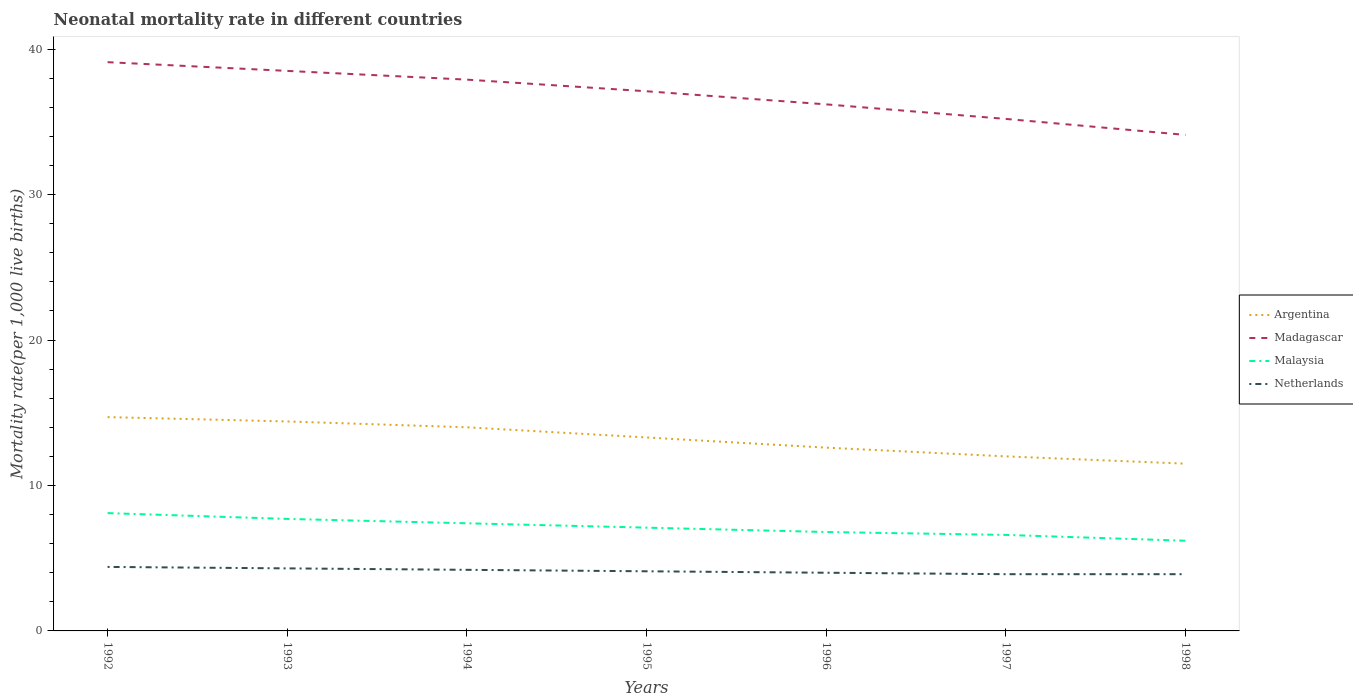How many different coloured lines are there?
Offer a terse response. 4. Does the line corresponding to Malaysia intersect with the line corresponding to Madagascar?
Offer a terse response. No. Is the number of lines equal to the number of legend labels?
Offer a very short reply. Yes. In which year was the neonatal mortality rate in Madagascar maximum?
Offer a very short reply. 1998. What is the difference between the highest and the second highest neonatal mortality rate in Madagascar?
Offer a terse response. 5. What is the difference between the highest and the lowest neonatal mortality rate in Madagascar?
Keep it short and to the point. 4. What is the difference between two consecutive major ticks on the Y-axis?
Give a very brief answer. 10. Does the graph contain any zero values?
Your response must be concise. No. How many legend labels are there?
Keep it short and to the point. 4. How are the legend labels stacked?
Provide a short and direct response. Vertical. What is the title of the graph?
Keep it short and to the point. Neonatal mortality rate in different countries. What is the label or title of the Y-axis?
Your answer should be very brief. Mortality rate(per 1,0 live births). What is the Mortality rate(per 1,000 live births) in Madagascar in 1992?
Offer a very short reply. 39.1. What is the Mortality rate(per 1,000 live births) in Malaysia in 1992?
Provide a succinct answer. 8.1. What is the Mortality rate(per 1,000 live births) in Madagascar in 1993?
Give a very brief answer. 38.5. What is the Mortality rate(per 1,000 live births) in Netherlands in 1993?
Ensure brevity in your answer.  4.3. What is the Mortality rate(per 1,000 live births) of Argentina in 1994?
Your answer should be compact. 14. What is the Mortality rate(per 1,000 live births) in Madagascar in 1994?
Give a very brief answer. 37.9. What is the Mortality rate(per 1,000 live births) of Madagascar in 1995?
Give a very brief answer. 37.1. What is the Mortality rate(per 1,000 live births) in Madagascar in 1996?
Provide a succinct answer. 36.2. What is the Mortality rate(per 1,000 live births) of Madagascar in 1997?
Offer a terse response. 35.2. What is the Mortality rate(per 1,000 live births) in Netherlands in 1997?
Your response must be concise. 3.9. What is the Mortality rate(per 1,000 live births) in Argentina in 1998?
Your answer should be compact. 11.5. What is the Mortality rate(per 1,000 live births) in Madagascar in 1998?
Offer a very short reply. 34.1. What is the Mortality rate(per 1,000 live births) of Malaysia in 1998?
Provide a succinct answer. 6.2. What is the Mortality rate(per 1,000 live births) in Netherlands in 1998?
Make the answer very short. 3.9. Across all years, what is the maximum Mortality rate(per 1,000 live births) of Argentina?
Your answer should be compact. 14.7. Across all years, what is the maximum Mortality rate(per 1,000 live births) in Madagascar?
Your answer should be compact. 39.1. Across all years, what is the minimum Mortality rate(per 1,000 live births) of Madagascar?
Keep it short and to the point. 34.1. Across all years, what is the minimum Mortality rate(per 1,000 live births) of Malaysia?
Offer a very short reply. 6.2. What is the total Mortality rate(per 1,000 live births) in Argentina in the graph?
Offer a very short reply. 92.5. What is the total Mortality rate(per 1,000 live births) in Madagascar in the graph?
Make the answer very short. 258.1. What is the total Mortality rate(per 1,000 live births) in Malaysia in the graph?
Ensure brevity in your answer.  49.9. What is the total Mortality rate(per 1,000 live births) of Netherlands in the graph?
Keep it short and to the point. 28.8. What is the difference between the Mortality rate(per 1,000 live births) in Argentina in 1992 and that in 1994?
Offer a very short reply. 0.7. What is the difference between the Mortality rate(per 1,000 live births) of Netherlands in 1992 and that in 1994?
Provide a short and direct response. 0.2. What is the difference between the Mortality rate(per 1,000 live births) of Malaysia in 1992 and that in 1995?
Ensure brevity in your answer.  1. What is the difference between the Mortality rate(per 1,000 live births) in Netherlands in 1992 and that in 1995?
Keep it short and to the point. 0.3. What is the difference between the Mortality rate(per 1,000 live births) of Argentina in 1992 and that in 1997?
Offer a very short reply. 2.7. What is the difference between the Mortality rate(per 1,000 live births) in Malaysia in 1992 and that in 1997?
Your response must be concise. 1.5. What is the difference between the Mortality rate(per 1,000 live births) in Netherlands in 1992 and that in 1997?
Ensure brevity in your answer.  0.5. What is the difference between the Mortality rate(per 1,000 live births) of Argentina in 1992 and that in 1998?
Ensure brevity in your answer.  3.2. What is the difference between the Mortality rate(per 1,000 live births) in Madagascar in 1992 and that in 1998?
Provide a succinct answer. 5. What is the difference between the Mortality rate(per 1,000 live births) in Madagascar in 1993 and that in 1994?
Give a very brief answer. 0.6. What is the difference between the Mortality rate(per 1,000 live births) in Malaysia in 1993 and that in 1994?
Your answer should be compact. 0.3. What is the difference between the Mortality rate(per 1,000 live births) in Netherlands in 1993 and that in 1994?
Ensure brevity in your answer.  0.1. What is the difference between the Mortality rate(per 1,000 live births) in Argentina in 1993 and that in 1995?
Your answer should be compact. 1.1. What is the difference between the Mortality rate(per 1,000 live births) in Madagascar in 1993 and that in 1995?
Keep it short and to the point. 1.4. What is the difference between the Mortality rate(per 1,000 live births) of Netherlands in 1993 and that in 1995?
Provide a short and direct response. 0.2. What is the difference between the Mortality rate(per 1,000 live births) in Madagascar in 1993 and that in 1996?
Your answer should be compact. 2.3. What is the difference between the Mortality rate(per 1,000 live births) in Malaysia in 1993 and that in 1996?
Your answer should be compact. 0.9. What is the difference between the Mortality rate(per 1,000 live births) of Netherlands in 1993 and that in 1996?
Provide a short and direct response. 0.3. What is the difference between the Mortality rate(per 1,000 live births) in Argentina in 1993 and that in 1997?
Offer a terse response. 2.4. What is the difference between the Mortality rate(per 1,000 live births) in Madagascar in 1993 and that in 1997?
Offer a very short reply. 3.3. What is the difference between the Mortality rate(per 1,000 live births) of Argentina in 1993 and that in 1998?
Make the answer very short. 2.9. What is the difference between the Mortality rate(per 1,000 live births) in Madagascar in 1993 and that in 1998?
Offer a very short reply. 4.4. What is the difference between the Mortality rate(per 1,000 live births) in Argentina in 1994 and that in 1995?
Make the answer very short. 0.7. What is the difference between the Mortality rate(per 1,000 live births) in Madagascar in 1994 and that in 1995?
Ensure brevity in your answer.  0.8. What is the difference between the Mortality rate(per 1,000 live births) of Malaysia in 1994 and that in 1995?
Your answer should be compact. 0.3. What is the difference between the Mortality rate(per 1,000 live births) of Argentina in 1994 and that in 1996?
Your response must be concise. 1.4. What is the difference between the Mortality rate(per 1,000 live births) of Malaysia in 1994 and that in 1996?
Offer a very short reply. 0.6. What is the difference between the Mortality rate(per 1,000 live births) in Madagascar in 1994 and that in 1997?
Make the answer very short. 2.7. What is the difference between the Mortality rate(per 1,000 live births) of Malaysia in 1994 and that in 1997?
Your answer should be very brief. 0.8. What is the difference between the Mortality rate(per 1,000 live births) of Malaysia in 1994 and that in 1998?
Keep it short and to the point. 1.2. What is the difference between the Mortality rate(per 1,000 live births) in Netherlands in 1994 and that in 1998?
Provide a succinct answer. 0.3. What is the difference between the Mortality rate(per 1,000 live births) in Argentina in 1995 and that in 1996?
Provide a succinct answer. 0.7. What is the difference between the Mortality rate(per 1,000 live births) in Madagascar in 1995 and that in 1996?
Offer a terse response. 0.9. What is the difference between the Mortality rate(per 1,000 live births) of Malaysia in 1995 and that in 1996?
Offer a very short reply. 0.3. What is the difference between the Mortality rate(per 1,000 live births) in Netherlands in 1995 and that in 1996?
Your response must be concise. 0.1. What is the difference between the Mortality rate(per 1,000 live births) in Argentina in 1995 and that in 1997?
Your answer should be very brief. 1.3. What is the difference between the Mortality rate(per 1,000 live births) of Madagascar in 1995 and that in 1997?
Your answer should be very brief. 1.9. What is the difference between the Mortality rate(per 1,000 live births) of Argentina in 1996 and that in 1997?
Keep it short and to the point. 0.6. What is the difference between the Mortality rate(per 1,000 live births) in Madagascar in 1996 and that in 1998?
Ensure brevity in your answer.  2.1. What is the difference between the Mortality rate(per 1,000 live births) of Argentina in 1997 and that in 1998?
Your answer should be compact. 0.5. What is the difference between the Mortality rate(per 1,000 live births) in Malaysia in 1997 and that in 1998?
Your answer should be very brief. 0.4. What is the difference between the Mortality rate(per 1,000 live births) in Netherlands in 1997 and that in 1998?
Your answer should be compact. 0. What is the difference between the Mortality rate(per 1,000 live births) of Argentina in 1992 and the Mortality rate(per 1,000 live births) of Madagascar in 1993?
Your response must be concise. -23.8. What is the difference between the Mortality rate(per 1,000 live births) in Argentina in 1992 and the Mortality rate(per 1,000 live births) in Netherlands in 1993?
Offer a terse response. 10.4. What is the difference between the Mortality rate(per 1,000 live births) in Madagascar in 1992 and the Mortality rate(per 1,000 live births) in Malaysia in 1993?
Offer a very short reply. 31.4. What is the difference between the Mortality rate(per 1,000 live births) of Madagascar in 1992 and the Mortality rate(per 1,000 live births) of Netherlands in 1993?
Offer a terse response. 34.8. What is the difference between the Mortality rate(per 1,000 live births) in Malaysia in 1992 and the Mortality rate(per 1,000 live births) in Netherlands in 1993?
Provide a succinct answer. 3.8. What is the difference between the Mortality rate(per 1,000 live births) of Argentina in 1992 and the Mortality rate(per 1,000 live births) of Madagascar in 1994?
Make the answer very short. -23.2. What is the difference between the Mortality rate(per 1,000 live births) of Argentina in 1992 and the Mortality rate(per 1,000 live births) of Netherlands in 1994?
Make the answer very short. 10.5. What is the difference between the Mortality rate(per 1,000 live births) of Madagascar in 1992 and the Mortality rate(per 1,000 live births) of Malaysia in 1994?
Provide a succinct answer. 31.7. What is the difference between the Mortality rate(per 1,000 live births) of Madagascar in 1992 and the Mortality rate(per 1,000 live births) of Netherlands in 1994?
Keep it short and to the point. 34.9. What is the difference between the Mortality rate(per 1,000 live births) in Malaysia in 1992 and the Mortality rate(per 1,000 live births) in Netherlands in 1994?
Provide a short and direct response. 3.9. What is the difference between the Mortality rate(per 1,000 live births) in Argentina in 1992 and the Mortality rate(per 1,000 live births) in Madagascar in 1995?
Keep it short and to the point. -22.4. What is the difference between the Mortality rate(per 1,000 live births) in Argentina in 1992 and the Mortality rate(per 1,000 live births) in Netherlands in 1995?
Make the answer very short. 10.6. What is the difference between the Mortality rate(per 1,000 live births) of Madagascar in 1992 and the Mortality rate(per 1,000 live births) of Netherlands in 1995?
Provide a succinct answer. 35. What is the difference between the Mortality rate(per 1,000 live births) of Malaysia in 1992 and the Mortality rate(per 1,000 live births) of Netherlands in 1995?
Offer a very short reply. 4. What is the difference between the Mortality rate(per 1,000 live births) of Argentina in 1992 and the Mortality rate(per 1,000 live births) of Madagascar in 1996?
Your response must be concise. -21.5. What is the difference between the Mortality rate(per 1,000 live births) of Madagascar in 1992 and the Mortality rate(per 1,000 live births) of Malaysia in 1996?
Your answer should be very brief. 32.3. What is the difference between the Mortality rate(per 1,000 live births) of Madagascar in 1992 and the Mortality rate(per 1,000 live births) of Netherlands in 1996?
Your response must be concise. 35.1. What is the difference between the Mortality rate(per 1,000 live births) of Malaysia in 1992 and the Mortality rate(per 1,000 live births) of Netherlands in 1996?
Offer a terse response. 4.1. What is the difference between the Mortality rate(per 1,000 live births) in Argentina in 1992 and the Mortality rate(per 1,000 live births) in Madagascar in 1997?
Your answer should be compact. -20.5. What is the difference between the Mortality rate(per 1,000 live births) of Argentina in 1992 and the Mortality rate(per 1,000 live births) of Netherlands in 1997?
Your answer should be very brief. 10.8. What is the difference between the Mortality rate(per 1,000 live births) of Madagascar in 1992 and the Mortality rate(per 1,000 live births) of Malaysia in 1997?
Give a very brief answer. 32.5. What is the difference between the Mortality rate(per 1,000 live births) of Madagascar in 1992 and the Mortality rate(per 1,000 live births) of Netherlands in 1997?
Keep it short and to the point. 35.2. What is the difference between the Mortality rate(per 1,000 live births) in Malaysia in 1992 and the Mortality rate(per 1,000 live births) in Netherlands in 1997?
Provide a short and direct response. 4.2. What is the difference between the Mortality rate(per 1,000 live births) in Argentina in 1992 and the Mortality rate(per 1,000 live births) in Madagascar in 1998?
Offer a very short reply. -19.4. What is the difference between the Mortality rate(per 1,000 live births) in Argentina in 1992 and the Mortality rate(per 1,000 live births) in Netherlands in 1998?
Ensure brevity in your answer.  10.8. What is the difference between the Mortality rate(per 1,000 live births) of Madagascar in 1992 and the Mortality rate(per 1,000 live births) of Malaysia in 1998?
Offer a terse response. 32.9. What is the difference between the Mortality rate(per 1,000 live births) of Madagascar in 1992 and the Mortality rate(per 1,000 live births) of Netherlands in 1998?
Offer a terse response. 35.2. What is the difference between the Mortality rate(per 1,000 live births) of Malaysia in 1992 and the Mortality rate(per 1,000 live births) of Netherlands in 1998?
Offer a terse response. 4.2. What is the difference between the Mortality rate(per 1,000 live births) in Argentina in 1993 and the Mortality rate(per 1,000 live births) in Madagascar in 1994?
Your answer should be compact. -23.5. What is the difference between the Mortality rate(per 1,000 live births) in Argentina in 1993 and the Mortality rate(per 1,000 live births) in Netherlands in 1994?
Offer a terse response. 10.2. What is the difference between the Mortality rate(per 1,000 live births) in Madagascar in 1993 and the Mortality rate(per 1,000 live births) in Malaysia in 1994?
Ensure brevity in your answer.  31.1. What is the difference between the Mortality rate(per 1,000 live births) of Madagascar in 1993 and the Mortality rate(per 1,000 live births) of Netherlands in 1994?
Make the answer very short. 34.3. What is the difference between the Mortality rate(per 1,000 live births) of Argentina in 1993 and the Mortality rate(per 1,000 live births) of Madagascar in 1995?
Give a very brief answer. -22.7. What is the difference between the Mortality rate(per 1,000 live births) in Argentina in 1993 and the Mortality rate(per 1,000 live births) in Malaysia in 1995?
Keep it short and to the point. 7.3. What is the difference between the Mortality rate(per 1,000 live births) in Argentina in 1993 and the Mortality rate(per 1,000 live births) in Netherlands in 1995?
Offer a terse response. 10.3. What is the difference between the Mortality rate(per 1,000 live births) in Madagascar in 1993 and the Mortality rate(per 1,000 live births) in Malaysia in 1995?
Provide a short and direct response. 31.4. What is the difference between the Mortality rate(per 1,000 live births) in Madagascar in 1993 and the Mortality rate(per 1,000 live births) in Netherlands in 1995?
Ensure brevity in your answer.  34.4. What is the difference between the Mortality rate(per 1,000 live births) of Malaysia in 1993 and the Mortality rate(per 1,000 live births) of Netherlands in 1995?
Your response must be concise. 3.6. What is the difference between the Mortality rate(per 1,000 live births) in Argentina in 1993 and the Mortality rate(per 1,000 live births) in Madagascar in 1996?
Keep it short and to the point. -21.8. What is the difference between the Mortality rate(per 1,000 live births) of Argentina in 1993 and the Mortality rate(per 1,000 live births) of Malaysia in 1996?
Offer a terse response. 7.6. What is the difference between the Mortality rate(per 1,000 live births) of Madagascar in 1993 and the Mortality rate(per 1,000 live births) of Malaysia in 1996?
Provide a short and direct response. 31.7. What is the difference between the Mortality rate(per 1,000 live births) of Madagascar in 1993 and the Mortality rate(per 1,000 live births) of Netherlands in 1996?
Make the answer very short. 34.5. What is the difference between the Mortality rate(per 1,000 live births) in Argentina in 1993 and the Mortality rate(per 1,000 live births) in Madagascar in 1997?
Your answer should be compact. -20.8. What is the difference between the Mortality rate(per 1,000 live births) of Madagascar in 1993 and the Mortality rate(per 1,000 live births) of Malaysia in 1997?
Your response must be concise. 31.9. What is the difference between the Mortality rate(per 1,000 live births) in Madagascar in 1993 and the Mortality rate(per 1,000 live births) in Netherlands in 1997?
Your answer should be compact. 34.6. What is the difference between the Mortality rate(per 1,000 live births) in Malaysia in 1993 and the Mortality rate(per 1,000 live births) in Netherlands in 1997?
Provide a short and direct response. 3.8. What is the difference between the Mortality rate(per 1,000 live births) of Argentina in 1993 and the Mortality rate(per 1,000 live births) of Madagascar in 1998?
Ensure brevity in your answer.  -19.7. What is the difference between the Mortality rate(per 1,000 live births) of Argentina in 1993 and the Mortality rate(per 1,000 live births) of Netherlands in 1998?
Provide a succinct answer. 10.5. What is the difference between the Mortality rate(per 1,000 live births) in Madagascar in 1993 and the Mortality rate(per 1,000 live births) in Malaysia in 1998?
Your response must be concise. 32.3. What is the difference between the Mortality rate(per 1,000 live births) in Madagascar in 1993 and the Mortality rate(per 1,000 live births) in Netherlands in 1998?
Provide a succinct answer. 34.6. What is the difference between the Mortality rate(per 1,000 live births) of Malaysia in 1993 and the Mortality rate(per 1,000 live births) of Netherlands in 1998?
Your response must be concise. 3.8. What is the difference between the Mortality rate(per 1,000 live births) in Argentina in 1994 and the Mortality rate(per 1,000 live births) in Madagascar in 1995?
Keep it short and to the point. -23.1. What is the difference between the Mortality rate(per 1,000 live births) of Argentina in 1994 and the Mortality rate(per 1,000 live births) of Malaysia in 1995?
Keep it short and to the point. 6.9. What is the difference between the Mortality rate(per 1,000 live births) of Argentina in 1994 and the Mortality rate(per 1,000 live births) of Netherlands in 1995?
Your response must be concise. 9.9. What is the difference between the Mortality rate(per 1,000 live births) of Madagascar in 1994 and the Mortality rate(per 1,000 live births) of Malaysia in 1995?
Offer a very short reply. 30.8. What is the difference between the Mortality rate(per 1,000 live births) of Madagascar in 1994 and the Mortality rate(per 1,000 live births) of Netherlands in 1995?
Keep it short and to the point. 33.8. What is the difference between the Mortality rate(per 1,000 live births) of Malaysia in 1994 and the Mortality rate(per 1,000 live births) of Netherlands in 1995?
Offer a terse response. 3.3. What is the difference between the Mortality rate(per 1,000 live births) in Argentina in 1994 and the Mortality rate(per 1,000 live births) in Madagascar in 1996?
Provide a succinct answer. -22.2. What is the difference between the Mortality rate(per 1,000 live births) in Argentina in 1994 and the Mortality rate(per 1,000 live births) in Netherlands in 1996?
Offer a very short reply. 10. What is the difference between the Mortality rate(per 1,000 live births) of Madagascar in 1994 and the Mortality rate(per 1,000 live births) of Malaysia in 1996?
Your answer should be very brief. 31.1. What is the difference between the Mortality rate(per 1,000 live births) in Madagascar in 1994 and the Mortality rate(per 1,000 live births) in Netherlands in 1996?
Ensure brevity in your answer.  33.9. What is the difference between the Mortality rate(per 1,000 live births) in Argentina in 1994 and the Mortality rate(per 1,000 live births) in Madagascar in 1997?
Your response must be concise. -21.2. What is the difference between the Mortality rate(per 1,000 live births) of Argentina in 1994 and the Mortality rate(per 1,000 live births) of Malaysia in 1997?
Your answer should be very brief. 7.4. What is the difference between the Mortality rate(per 1,000 live births) of Madagascar in 1994 and the Mortality rate(per 1,000 live births) of Malaysia in 1997?
Provide a succinct answer. 31.3. What is the difference between the Mortality rate(per 1,000 live births) of Madagascar in 1994 and the Mortality rate(per 1,000 live births) of Netherlands in 1997?
Give a very brief answer. 34. What is the difference between the Mortality rate(per 1,000 live births) of Malaysia in 1994 and the Mortality rate(per 1,000 live births) of Netherlands in 1997?
Offer a very short reply. 3.5. What is the difference between the Mortality rate(per 1,000 live births) of Argentina in 1994 and the Mortality rate(per 1,000 live births) of Madagascar in 1998?
Provide a succinct answer. -20.1. What is the difference between the Mortality rate(per 1,000 live births) in Argentina in 1994 and the Mortality rate(per 1,000 live births) in Malaysia in 1998?
Give a very brief answer. 7.8. What is the difference between the Mortality rate(per 1,000 live births) of Argentina in 1994 and the Mortality rate(per 1,000 live births) of Netherlands in 1998?
Offer a terse response. 10.1. What is the difference between the Mortality rate(per 1,000 live births) of Madagascar in 1994 and the Mortality rate(per 1,000 live births) of Malaysia in 1998?
Your response must be concise. 31.7. What is the difference between the Mortality rate(per 1,000 live births) of Madagascar in 1994 and the Mortality rate(per 1,000 live births) of Netherlands in 1998?
Offer a very short reply. 34. What is the difference between the Mortality rate(per 1,000 live births) of Argentina in 1995 and the Mortality rate(per 1,000 live births) of Madagascar in 1996?
Your response must be concise. -22.9. What is the difference between the Mortality rate(per 1,000 live births) of Argentina in 1995 and the Mortality rate(per 1,000 live births) of Malaysia in 1996?
Offer a very short reply. 6.5. What is the difference between the Mortality rate(per 1,000 live births) of Madagascar in 1995 and the Mortality rate(per 1,000 live births) of Malaysia in 1996?
Provide a short and direct response. 30.3. What is the difference between the Mortality rate(per 1,000 live births) of Madagascar in 1995 and the Mortality rate(per 1,000 live births) of Netherlands in 1996?
Provide a succinct answer. 33.1. What is the difference between the Mortality rate(per 1,000 live births) in Argentina in 1995 and the Mortality rate(per 1,000 live births) in Madagascar in 1997?
Your answer should be very brief. -21.9. What is the difference between the Mortality rate(per 1,000 live births) of Argentina in 1995 and the Mortality rate(per 1,000 live births) of Malaysia in 1997?
Your answer should be compact. 6.7. What is the difference between the Mortality rate(per 1,000 live births) of Madagascar in 1995 and the Mortality rate(per 1,000 live births) of Malaysia in 1997?
Your answer should be compact. 30.5. What is the difference between the Mortality rate(per 1,000 live births) of Madagascar in 1995 and the Mortality rate(per 1,000 live births) of Netherlands in 1997?
Provide a short and direct response. 33.2. What is the difference between the Mortality rate(per 1,000 live births) of Malaysia in 1995 and the Mortality rate(per 1,000 live births) of Netherlands in 1997?
Provide a succinct answer. 3.2. What is the difference between the Mortality rate(per 1,000 live births) in Argentina in 1995 and the Mortality rate(per 1,000 live births) in Madagascar in 1998?
Provide a succinct answer. -20.8. What is the difference between the Mortality rate(per 1,000 live births) in Argentina in 1995 and the Mortality rate(per 1,000 live births) in Malaysia in 1998?
Your response must be concise. 7.1. What is the difference between the Mortality rate(per 1,000 live births) of Madagascar in 1995 and the Mortality rate(per 1,000 live births) of Malaysia in 1998?
Give a very brief answer. 30.9. What is the difference between the Mortality rate(per 1,000 live births) in Madagascar in 1995 and the Mortality rate(per 1,000 live births) in Netherlands in 1998?
Ensure brevity in your answer.  33.2. What is the difference between the Mortality rate(per 1,000 live births) of Argentina in 1996 and the Mortality rate(per 1,000 live births) of Madagascar in 1997?
Your response must be concise. -22.6. What is the difference between the Mortality rate(per 1,000 live births) in Argentina in 1996 and the Mortality rate(per 1,000 live births) in Netherlands in 1997?
Your answer should be very brief. 8.7. What is the difference between the Mortality rate(per 1,000 live births) in Madagascar in 1996 and the Mortality rate(per 1,000 live births) in Malaysia in 1997?
Ensure brevity in your answer.  29.6. What is the difference between the Mortality rate(per 1,000 live births) of Madagascar in 1996 and the Mortality rate(per 1,000 live births) of Netherlands in 1997?
Keep it short and to the point. 32.3. What is the difference between the Mortality rate(per 1,000 live births) in Malaysia in 1996 and the Mortality rate(per 1,000 live births) in Netherlands in 1997?
Give a very brief answer. 2.9. What is the difference between the Mortality rate(per 1,000 live births) in Argentina in 1996 and the Mortality rate(per 1,000 live births) in Madagascar in 1998?
Ensure brevity in your answer.  -21.5. What is the difference between the Mortality rate(per 1,000 live births) of Argentina in 1996 and the Mortality rate(per 1,000 live births) of Netherlands in 1998?
Provide a succinct answer. 8.7. What is the difference between the Mortality rate(per 1,000 live births) of Madagascar in 1996 and the Mortality rate(per 1,000 live births) of Malaysia in 1998?
Provide a short and direct response. 30. What is the difference between the Mortality rate(per 1,000 live births) of Madagascar in 1996 and the Mortality rate(per 1,000 live births) of Netherlands in 1998?
Your answer should be very brief. 32.3. What is the difference between the Mortality rate(per 1,000 live births) in Malaysia in 1996 and the Mortality rate(per 1,000 live births) in Netherlands in 1998?
Your response must be concise. 2.9. What is the difference between the Mortality rate(per 1,000 live births) in Argentina in 1997 and the Mortality rate(per 1,000 live births) in Madagascar in 1998?
Make the answer very short. -22.1. What is the difference between the Mortality rate(per 1,000 live births) in Argentina in 1997 and the Mortality rate(per 1,000 live births) in Netherlands in 1998?
Ensure brevity in your answer.  8.1. What is the difference between the Mortality rate(per 1,000 live births) of Madagascar in 1997 and the Mortality rate(per 1,000 live births) of Netherlands in 1998?
Provide a succinct answer. 31.3. What is the average Mortality rate(per 1,000 live births) of Argentina per year?
Your response must be concise. 13.21. What is the average Mortality rate(per 1,000 live births) in Madagascar per year?
Offer a terse response. 36.87. What is the average Mortality rate(per 1,000 live births) of Malaysia per year?
Provide a succinct answer. 7.13. What is the average Mortality rate(per 1,000 live births) of Netherlands per year?
Offer a terse response. 4.11. In the year 1992, what is the difference between the Mortality rate(per 1,000 live births) of Argentina and Mortality rate(per 1,000 live births) of Madagascar?
Give a very brief answer. -24.4. In the year 1992, what is the difference between the Mortality rate(per 1,000 live births) of Argentina and Mortality rate(per 1,000 live births) of Netherlands?
Your response must be concise. 10.3. In the year 1992, what is the difference between the Mortality rate(per 1,000 live births) of Madagascar and Mortality rate(per 1,000 live births) of Netherlands?
Your response must be concise. 34.7. In the year 1993, what is the difference between the Mortality rate(per 1,000 live births) in Argentina and Mortality rate(per 1,000 live births) in Madagascar?
Keep it short and to the point. -24.1. In the year 1993, what is the difference between the Mortality rate(per 1,000 live births) of Argentina and Mortality rate(per 1,000 live births) of Malaysia?
Your answer should be compact. 6.7. In the year 1993, what is the difference between the Mortality rate(per 1,000 live births) in Madagascar and Mortality rate(per 1,000 live births) in Malaysia?
Provide a succinct answer. 30.8. In the year 1993, what is the difference between the Mortality rate(per 1,000 live births) of Madagascar and Mortality rate(per 1,000 live births) of Netherlands?
Offer a terse response. 34.2. In the year 1994, what is the difference between the Mortality rate(per 1,000 live births) of Argentina and Mortality rate(per 1,000 live births) of Madagascar?
Make the answer very short. -23.9. In the year 1994, what is the difference between the Mortality rate(per 1,000 live births) of Argentina and Mortality rate(per 1,000 live births) of Malaysia?
Your answer should be compact. 6.6. In the year 1994, what is the difference between the Mortality rate(per 1,000 live births) of Argentina and Mortality rate(per 1,000 live births) of Netherlands?
Give a very brief answer. 9.8. In the year 1994, what is the difference between the Mortality rate(per 1,000 live births) in Madagascar and Mortality rate(per 1,000 live births) in Malaysia?
Ensure brevity in your answer.  30.5. In the year 1994, what is the difference between the Mortality rate(per 1,000 live births) in Madagascar and Mortality rate(per 1,000 live births) in Netherlands?
Your answer should be very brief. 33.7. In the year 1994, what is the difference between the Mortality rate(per 1,000 live births) of Malaysia and Mortality rate(per 1,000 live births) of Netherlands?
Provide a succinct answer. 3.2. In the year 1995, what is the difference between the Mortality rate(per 1,000 live births) in Argentina and Mortality rate(per 1,000 live births) in Madagascar?
Give a very brief answer. -23.8. In the year 1995, what is the difference between the Mortality rate(per 1,000 live births) of Argentina and Mortality rate(per 1,000 live births) of Netherlands?
Your answer should be compact. 9.2. In the year 1995, what is the difference between the Mortality rate(per 1,000 live births) of Madagascar and Mortality rate(per 1,000 live births) of Netherlands?
Ensure brevity in your answer.  33. In the year 1995, what is the difference between the Mortality rate(per 1,000 live births) of Malaysia and Mortality rate(per 1,000 live births) of Netherlands?
Keep it short and to the point. 3. In the year 1996, what is the difference between the Mortality rate(per 1,000 live births) of Argentina and Mortality rate(per 1,000 live births) of Madagascar?
Offer a very short reply. -23.6. In the year 1996, what is the difference between the Mortality rate(per 1,000 live births) in Argentina and Mortality rate(per 1,000 live births) in Netherlands?
Provide a succinct answer. 8.6. In the year 1996, what is the difference between the Mortality rate(per 1,000 live births) in Madagascar and Mortality rate(per 1,000 live births) in Malaysia?
Give a very brief answer. 29.4. In the year 1996, what is the difference between the Mortality rate(per 1,000 live births) of Madagascar and Mortality rate(per 1,000 live births) of Netherlands?
Ensure brevity in your answer.  32.2. In the year 1996, what is the difference between the Mortality rate(per 1,000 live births) of Malaysia and Mortality rate(per 1,000 live births) of Netherlands?
Your response must be concise. 2.8. In the year 1997, what is the difference between the Mortality rate(per 1,000 live births) in Argentina and Mortality rate(per 1,000 live births) in Madagascar?
Give a very brief answer. -23.2. In the year 1997, what is the difference between the Mortality rate(per 1,000 live births) in Madagascar and Mortality rate(per 1,000 live births) in Malaysia?
Provide a succinct answer. 28.6. In the year 1997, what is the difference between the Mortality rate(per 1,000 live births) of Madagascar and Mortality rate(per 1,000 live births) of Netherlands?
Offer a very short reply. 31.3. In the year 1997, what is the difference between the Mortality rate(per 1,000 live births) of Malaysia and Mortality rate(per 1,000 live births) of Netherlands?
Offer a very short reply. 2.7. In the year 1998, what is the difference between the Mortality rate(per 1,000 live births) of Argentina and Mortality rate(per 1,000 live births) of Madagascar?
Your answer should be compact. -22.6. In the year 1998, what is the difference between the Mortality rate(per 1,000 live births) of Argentina and Mortality rate(per 1,000 live births) of Netherlands?
Your answer should be very brief. 7.6. In the year 1998, what is the difference between the Mortality rate(per 1,000 live births) in Madagascar and Mortality rate(per 1,000 live births) in Malaysia?
Ensure brevity in your answer.  27.9. In the year 1998, what is the difference between the Mortality rate(per 1,000 live births) in Madagascar and Mortality rate(per 1,000 live births) in Netherlands?
Keep it short and to the point. 30.2. What is the ratio of the Mortality rate(per 1,000 live births) of Argentina in 1992 to that in 1993?
Provide a succinct answer. 1.02. What is the ratio of the Mortality rate(per 1,000 live births) of Madagascar in 1992 to that in 1993?
Keep it short and to the point. 1.02. What is the ratio of the Mortality rate(per 1,000 live births) in Malaysia in 1992 to that in 1993?
Your answer should be compact. 1.05. What is the ratio of the Mortality rate(per 1,000 live births) of Netherlands in 1992 to that in 1993?
Your answer should be compact. 1.02. What is the ratio of the Mortality rate(per 1,000 live births) of Madagascar in 1992 to that in 1994?
Ensure brevity in your answer.  1.03. What is the ratio of the Mortality rate(per 1,000 live births) of Malaysia in 1992 to that in 1994?
Your answer should be very brief. 1.09. What is the ratio of the Mortality rate(per 1,000 live births) of Netherlands in 1992 to that in 1994?
Provide a short and direct response. 1.05. What is the ratio of the Mortality rate(per 1,000 live births) in Argentina in 1992 to that in 1995?
Give a very brief answer. 1.11. What is the ratio of the Mortality rate(per 1,000 live births) of Madagascar in 1992 to that in 1995?
Offer a very short reply. 1.05. What is the ratio of the Mortality rate(per 1,000 live births) in Malaysia in 1992 to that in 1995?
Provide a short and direct response. 1.14. What is the ratio of the Mortality rate(per 1,000 live births) in Netherlands in 1992 to that in 1995?
Keep it short and to the point. 1.07. What is the ratio of the Mortality rate(per 1,000 live births) of Argentina in 1992 to that in 1996?
Ensure brevity in your answer.  1.17. What is the ratio of the Mortality rate(per 1,000 live births) of Madagascar in 1992 to that in 1996?
Ensure brevity in your answer.  1.08. What is the ratio of the Mortality rate(per 1,000 live births) in Malaysia in 1992 to that in 1996?
Your answer should be very brief. 1.19. What is the ratio of the Mortality rate(per 1,000 live births) in Argentina in 1992 to that in 1997?
Your answer should be very brief. 1.23. What is the ratio of the Mortality rate(per 1,000 live births) of Madagascar in 1992 to that in 1997?
Offer a very short reply. 1.11. What is the ratio of the Mortality rate(per 1,000 live births) in Malaysia in 1992 to that in 1997?
Offer a very short reply. 1.23. What is the ratio of the Mortality rate(per 1,000 live births) of Netherlands in 1992 to that in 1997?
Offer a terse response. 1.13. What is the ratio of the Mortality rate(per 1,000 live births) of Argentina in 1992 to that in 1998?
Keep it short and to the point. 1.28. What is the ratio of the Mortality rate(per 1,000 live births) of Madagascar in 1992 to that in 1998?
Provide a succinct answer. 1.15. What is the ratio of the Mortality rate(per 1,000 live births) in Malaysia in 1992 to that in 1998?
Your answer should be compact. 1.31. What is the ratio of the Mortality rate(per 1,000 live births) of Netherlands in 1992 to that in 1998?
Keep it short and to the point. 1.13. What is the ratio of the Mortality rate(per 1,000 live births) of Argentina in 1993 to that in 1994?
Offer a terse response. 1.03. What is the ratio of the Mortality rate(per 1,000 live births) in Madagascar in 1993 to that in 1994?
Ensure brevity in your answer.  1.02. What is the ratio of the Mortality rate(per 1,000 live births) in Malaysia in 1993 to that in 1994?
Offer a very short reply. 1.04. What is the ratio of the Mortality rate(per 1,000 live births) in Netherlands in 1993 to that in 1994?
Keep it short and to the point. 1.02. What is the ratio of the Mortality rate(per 1,000 live births) in Argentina in 1993 to that in 1995?
Offer a very short reply. 1.08. What is the ratio of the Mortality rate(per 1,000 live births) of Madagascar in 1993 to that in 1995?
Keep it short and to the point. 1.04. What is the ratio of the Mortality rate(per 1,000 live births) in Malaysia in 1993 to that in 1995?
Your answer should be very brief. 1.08. What is the ratio of the Mortality rate(per 1,000 live births) in Netherlands in 1993 to that in 1995?
Make the answer very short. 1.05. What is the ratio of the Mortality rate(per 1,000 live births) of Madagascar in 1993 to that in 1996?
Your answer should be very brief. 1.06. What is the ratio of the Mortality rate(per 1,000 live births) of Malaysia in 1993 to that in 1996?
Your answer should be compact. 1.13. What is the ratio of the Mortality rate(per 1,000 live births) in Netherlands in 1993 to that in 1996?
Your answer should be compact. 1.07. What is the ratio of the Mortality rate(per 1,000 live births) in Argentina in 1993 to that in 1997?
Your response must be concise. 1.2. What is the ratio of the Mortality rate(per 1,000 live births) of Madagascar in 1993 to that in 1997?
Offer a very short reply. 1.09. What is the ratio of the Mortality rate(per 1,000 live births) of Malaysia in 1993 to that in 1997?
Keep it short and to the point. 1.17. What is the ratio of the Mortality rate(per 1,000 live births) of Netherlands in 1993 to that in 1997?
Provide a short and direct response. 1.1. What is the ratio of the Mortality rate(per 1,000 live births) of Argentina in 1993 to that in 1998?
Keep it short and to the point. 1.25. What is the ratio of the Mortality rate(per 1,000 live births) in Madagascar in 1993 to that in 1998?
Your response must be concise. 1.13. What is the ratio of the Mortality rate(per 1,000 live births) of Malaysia in 1993 to that in 1998?
Make the answer very short. 1.24. What is the ratio of the Mortality rate(per 1,000 live births) of Netherlands in 1993 to that in 1998?
Make the answer very short. 1.1. What is the ratio of the Mortality rate(per 1,000 live births) of Argentina in 1994 to that in 1995?
Keep it short and to the point. 1.05. What is the ratio of the Mortality rate(per 1,000 live births) in Madagascar in 1994 to that in 1995?
Provide a short and direct response. 1.02. What is the ratio of the Mortality rate(per 1,000 live births) of Malaysia in 1994 to that in 1995?
Your response must be concise. 1.04. What is the ratio of the Mortality rate(per 1,000 live births) of Netherlands in 1994 to that in 1995?
Offer a very short reply. 1.02. What is the ratio of the Mortality rate(per 1,000 live births) in Madagascar in 1994 to that in 1996?
Your answer should be very brief. 1.05. What is the ratio of the Mortality rate(per 1,000 live births) of Malaysia in 1994 to that in 1996?
Your answer should be compact. 1.09. What is the ratio of the Mortality rate(per 1,000 live births) of Madagascar in 1994 to that in 1997?
Your answer should be very brief. 1.08. What is the ratio of the Mortality rate(per 1,000 live births) in Malaysia in 1994 to that in 1997?
Ensure brevity in your answer.  1.12. What is the ratio of the Mortality rate(per 1,000 live births) in Netherlands in 1994 to that in 1997?
Your response must be concise. 1.08. What is the ratio of the Mortality rate(per 1,000 live births) in Argentina in 1994 to that in 1998?
Keep it short and to the point. 1.22. What is the ratio of the Mortality rate(per 1,000 live births) in Madagascar in 1994 to that in 1998?
Keep it short and to the point. 1.11. What is the ratio of the Mortality rate(per 1,000 live births) in Malaysia in 1994 to that in 1998?
Your answer should be very brief. 1.19. What is the ratio of the Mortality rate(per 1,000 live births) in Argentina in 1995 to that in 1996?
Offer a terse response. 1.06. What is the ratio of the Mortality rate(per 1,000 live births) in Madagascar in 1995 to that in 1996?
Keep it short and to the point. 1.02. What is the ratio of the Mortality rate(per 1,000 live births) in Malaysia in 1995 to that in 1996?
Your answer should be compact. 1.04. What is the ratio of the Mortality rate(per 1,000 live births) of Argentina in 1995 to that in 1997?
Provide a succinct answer. 1.11. What is the ratio of the Mortality rate(per 1,000 live births) in Madagascar in 1995 to that in 1997?
Offer a very short reply. 1.05. What is the ratio of the Mortality rate(per 1,000 live births) in Malaysia in 1995 to that in 1997?
Your answer should be very brief. 1.08. What is the ratio of the Mortality rate(per 1,000 live births) of Netherlands in 1995 to that in 1997?
Your answer should be very brief. 1.05. What is the ratio of the Mortality rate(per 1,000 live births) of Argentina in 1995 to that in 1998?
Provide a succinct answer. 1.16. What is the ratio of the Mortality rate(per 1,000 live births) in Madagascar in 1995 to that in 1998?
Your answer should be compact. 1.09. What is the ratio of the Mortality rate(per 1,000 live births) in Malaysia in 1995 to that in 1998?
Your answer should be compact. 1.15. What is the ratio of the Mortality rate(per 1,000 live births) in Netherlands in 1995 to that in 1998?
Provide a short and direct response. 1.05. What is the ratio of the Mortality rate(per 1,000 live births) in Argentina in 1996 to that in 1997?
Offer a terse response. 1.05. What is the ratio of the Mortality rate(per 1,000 live births) in Madagascar in 1996 to that in 1997?
Your answer should be very brief. 1.03. What is the ratio of the Mortality rate(per 1,000 live births) in Malaysia in 1996 to that in 1997?
Offer a terse response. 1.03. What is the ratio of the Mortality rate(per 1,000 live births) in Netherlands in 1996 to that in 1997?
Ensure brevity in your answer.  1.03. What is the ratio of the Mortality rate(per 1,000 live births) of Argentina in 1996 to that in 1998?
Keep it short and to the point. 1.1. What is the ratio of the Mortality rate(per 1,000 live births) of Madagascar in 1996 to that in 1998?
Your answer should be compact. 1.06. What is the ratio of the Mortality rate(per 1,000 live births) in Malaysia in 1996 to that in 1998?
Provide a short and direct response. 1.1. What is the ratio of the Mortality rate(per 1,000 live births) in Netherlands in 1996 to that in 1998?
Your response must be concise. 1.03. What is the ratio of the Mortality rate(per 1,000 live births) in Argentina in 1997 to that in 1998?
Keep it short and to the point. 1.04. What is the ratio of the Mortality rate(per 1,000 live births) in Madagascar in 1997 to that in 1998?
Give a very brief answer. 1.03. What is the ratio of the Mortality rate(per 1,000 live births) in Malaysia in 1997 to that in 1998?
Offer a terse response. 1.06. What is the ratio of the Mortality rate(per 1,000 live births) of Netherlands in 1997 to that in 1998?
Your response must be concise. 1. What is the difference between the highest and the second highest Mortality rate(per 1,000 live births) of Argentina?
Provide a short and direct response. 0.3. What is the difference between the highest and the second highest Mortality rate(per 1,000 live births) in Madagascar?
Your answer should be compact. 0.6. What is the difference between the highest and the second highest Mortality rate(per 1,000 live births) of Netherlands?
Provide a succinct answer. 0.1. What is the difference between the highest and the lowest Mortality rate(per 1,000 live births) in Madagascar?
Give a very brief answer. 5. 